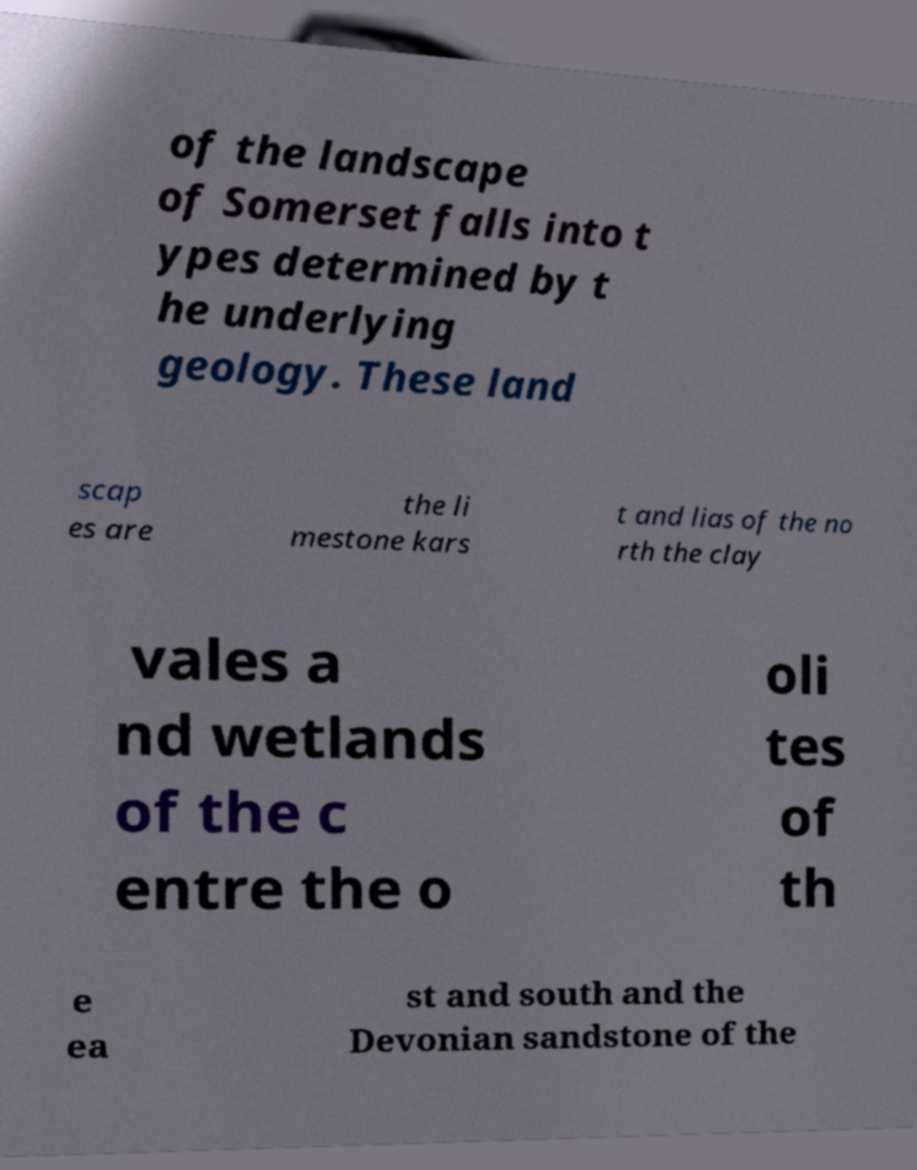For documentation purposes, I need the text within this image transcribed. Could you provide that? of the landscape of Somerset falls into t ypes determined by t he underlying geology. These land scap es are the li mestone kars t and lias of the no rth the clay vales a nd wetlands of the c entre the o oli tes of th e ea st and south and the Devonian sandstone of the 